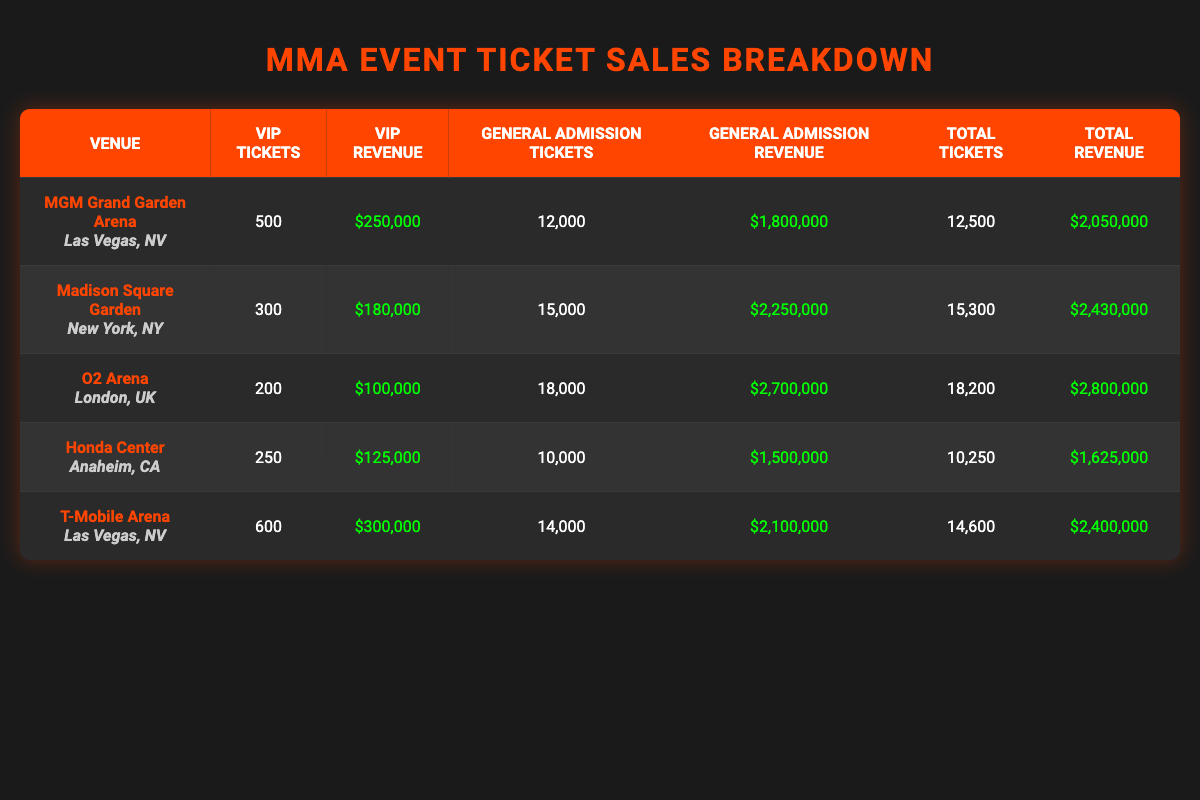What is the total revenue generated from ticket sales at the MGM Grand Garden Arena? By looking at the entry for the MGM Grand Garden Arena, the VIP revenue is $250,000 and the General Admission revenue is $1,800,000. Adding these two amounts gives $250,000 + $1,800,000 = $2,050,000.
Answer: $2,050,000 How many VIP tickets were sold at Madison Square Garden? The row for Madison Square Garden shows that 300 VIP tickets were sold, which is stated directly in the table.
Answer: 300 What is the difference between total ticket sales at O2 Arena and Honda Center? The O2 Arena had a total of 18,200 tickets sold, while the Honda Center had 10,250 tickets sold. To find the difference, subtract the Honda Center's total from O2 Arena's total: 18,200 - 10,250 = 7,950.
Answer: 7,950 Is the revenue from general admission tickets at T-Mobile Arena higher than at O2 Arena? At T-Mobile Arena, the General Admission revenue is $2,100,000 and at O2 Arena, it is $2,700,000. Since $2,100,000 is less than $2,700,000, the statement is false.
Answer: No What is the average revenue from VIP ticket sales across all venues? The VIP revenues from all venues are $250,000 (MGM), $180,000 (Madison), $100,000 (O2), $125,000 (Honda), and $300,000 (T-Mobile). Summing these gives $250,000 + $180,000 + $100,000 + $125,000 + $300,000 = $955,000. There are 5 venues, so the average is $955,000 / 5 = $191,000.
Answer: $191,000 Which venue has the highest number of general admission tickets sold? Looking at the table, the O2 Arena has 18,000 general admission tickets sold, which is the highest compared to the other venues.
Answer: O2 Arena How much total revenue came from only VIP ticket sales across all venues? The VIP revenues are as follows: MGM Grand Garden Arena: $250,000, Madison Square Garden: $180,000, O2 Arena: $100,000, Honda Center: $125,000, and T-Mobile Arena: $300,000. Summing these amounts gives $250,000 + $180,000 + $100,000 + $125,000 + $300,000 = $955,000.
Answer: $955,000 Is the sum of total tickets sold at Madison Square Garden and Honda Center greater than the total tickets sold at MGM Grand Garden Arena? Madison Square Garden sold a total of 15,300 tickets and Honda Center sold 10,250 tickets. Their combined total is 15,300 + 10,250 = 25,550. MGM Grand Garden Arena sold 12,500 tickets, and since 25,550 is greater than 12,500, the statement is true.
Answer: Yes 